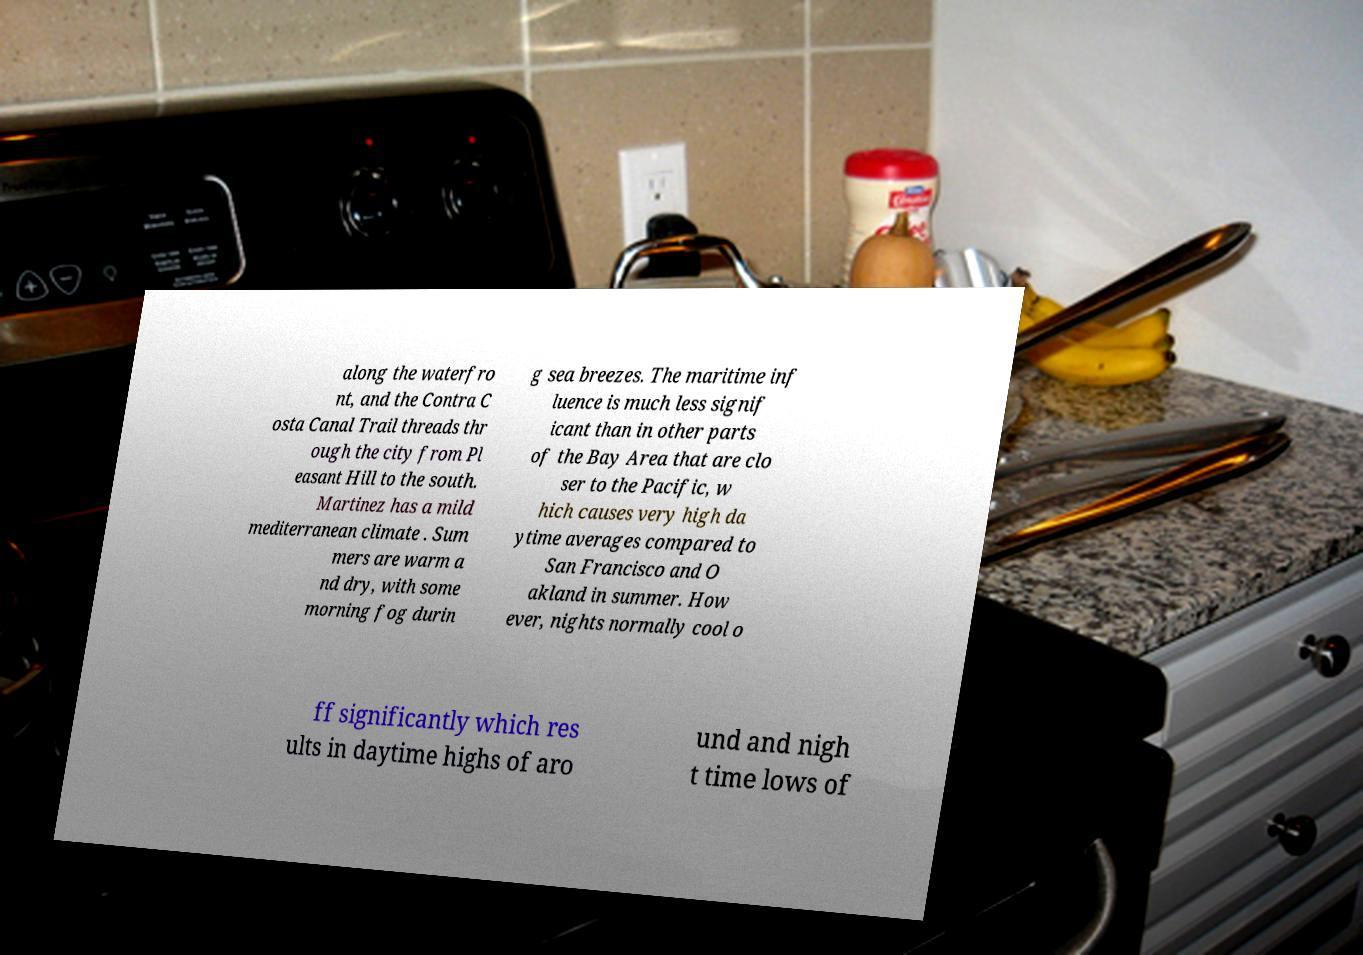Could you extract and type out the text from this image? along the waterfro nt, and the Contra C osta Canal Trail threads thr ough the city from Pl easant Hill to the south. Martinez has a mild mediterranean climate . Sum mers are warm a nd dry, with some morning fog durin g sea breezes. The maritime inf luence is much less signif icant than in other parts of the Bay Area that are clo ser to the Pacific, w hich causes very high da ytime averages compared to San Francisco and O akland in summer. How ever, nights normally cool o ff significantly which res ults in daytime highs of aro und and nigh t time lows of 